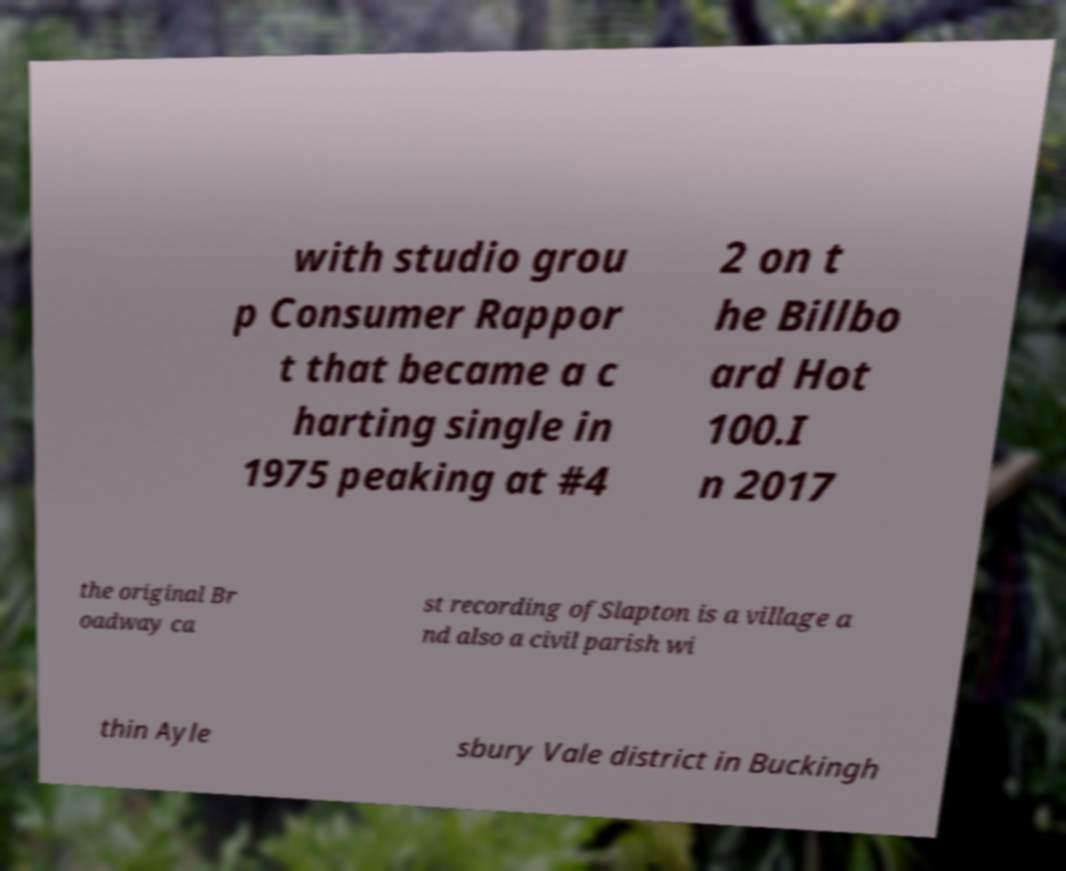What messages or text are displayed in this image? I need them in a readable, typed format. with studio grou p Consumer Rappor t that became a c harting single in 1975 peaking at #4 2 on t he Billbo ard Hot 100.I n 2017 the original Br oadway ca st recording ofSlapton is a village a nd also a civil parish wi thin Ayle sbury Vale district in Buckingh 